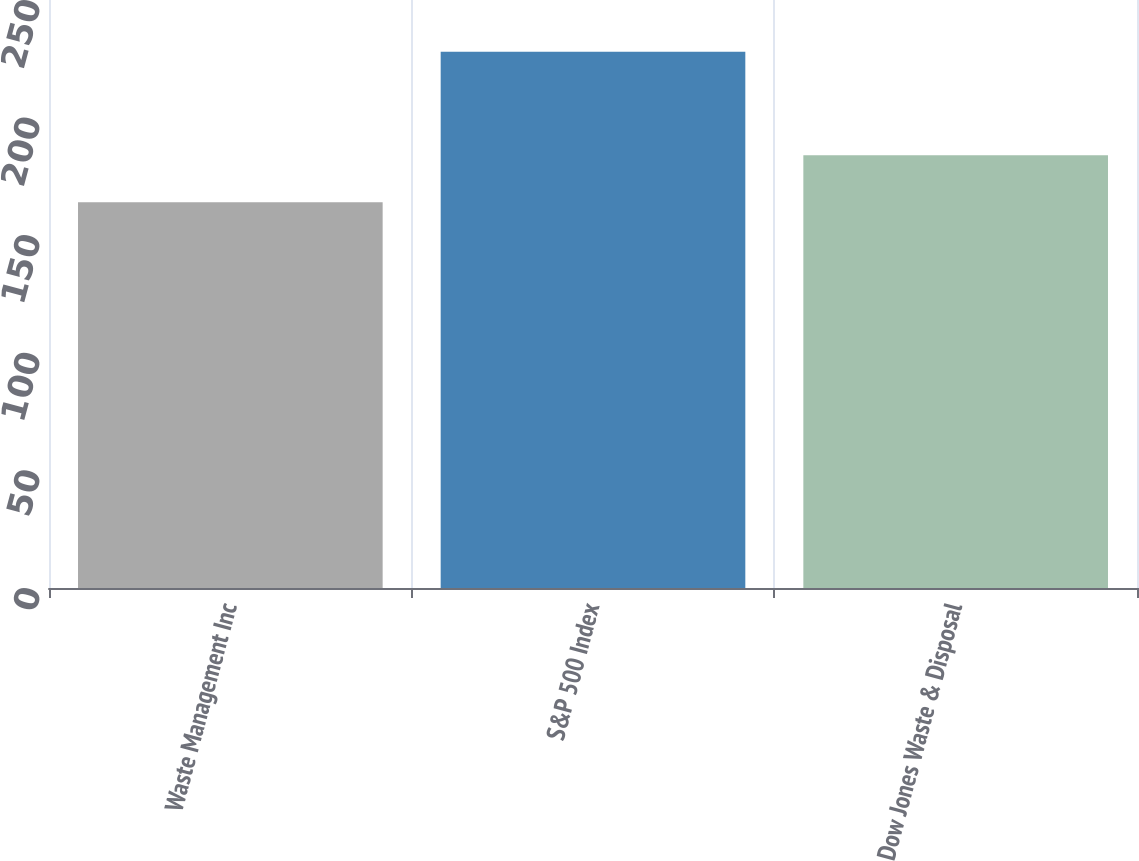Convert chart to OTSL. <chart><loc_0><loc_0><loc_500><loc_500><bar_chart><fcel>Waste Management Inc<fcel>S&P 500 Index<fcel>Dow Jones Waste & Disposal<nl><fcel>164<fcel>228<fcel>184<nl></chart> 